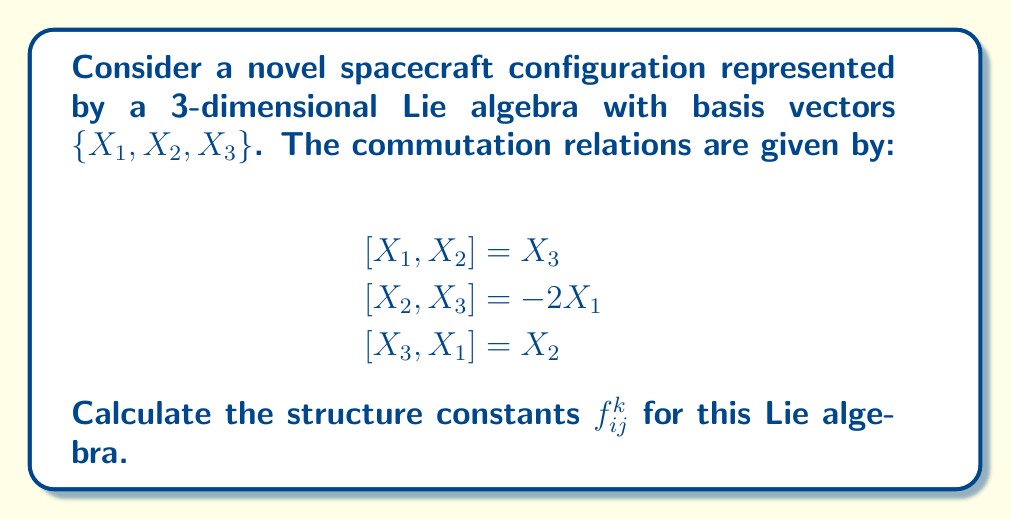Can you answer this question? To calculate the structure constants for this Lie algebra, we need to express the commutation relations in terms of the structure constants. The general form of a commutation relation is:

$$[X_i, X_j] = \sum_{k=1}^3 f_{ij}^k X_k$$

where $f_{ij}^k$ are the structure constants.

Let's analyze each commutation relation:

1) $[X_1, X_2] = X_3$
   This implies $f_{12}^3 = 1$, and all other $f_{12}^k = 0$

2) $[X_2, X_3] = -2X_1$
   This implies $f_{23}^1 = -2$, and all other $f_{23}^k = 0$

3) $[X_3, X_1] = X_2$
   This implies $f_{31}^2 = 1$, and all other $f_{31}^k = 0$

Note that the structure constants are antisymmetric in the lower indices, meaning:

$$f_{ij}^k = -f_{ji}^k$$

Therefore, we can also deduce:

4) $f_{21}^3 = -1$
5) $f_{32}^1 = 2$
6) $f_{13}^2 = -1$

All other structure constants are zero.

We can represent these structure constants in a 3x3x3 array, where the entry at position (i,j,k) represents $f_{ij}^k$:

$$f_{ij}^k = \begin{bmatrix}
   \begin{bmatrix} 0 & 0 & 0 \\ 0 & 0 & 1 \\ 0 & -1 & 0 \end{bmatrix} \\
   \begin{bmatrix} 0 & 0 & -1 \\ 0 & 0 & 0 \\ 2 & 0 & 0 \end{bmatrix} \\
   \begin{bmatrix} 0 & 1 & 0 \\ -2 & 0 & 0 \\ 0 & 0 & 0 \end{bmatrix}
\end{bmatrix}$$
Answer: The non-zero structure constants are:

$f_{12}^3 = 1$, $f_{23}^1 = -2$, $f_{31}^2 = 1$
$f_{21}^3 = -1$, $f_{32}^1 = 2$, $f_{13}^2 = -1$

All other $f_{ij}^k = 0$. 